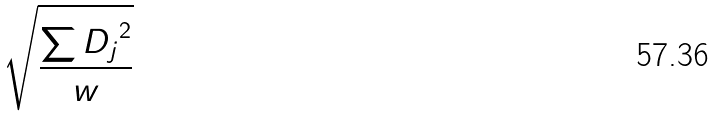<formula> <loc_0><loc_0><loc_500><loc_500>\sqrt { \frac { \sum { D _ { j } } ^ { 2 } } { w } }</formula> 